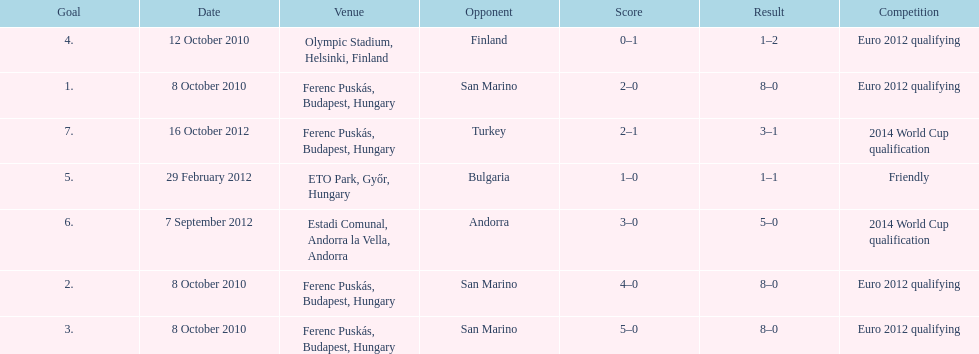How many non-qualifying games did he score in? 1. 